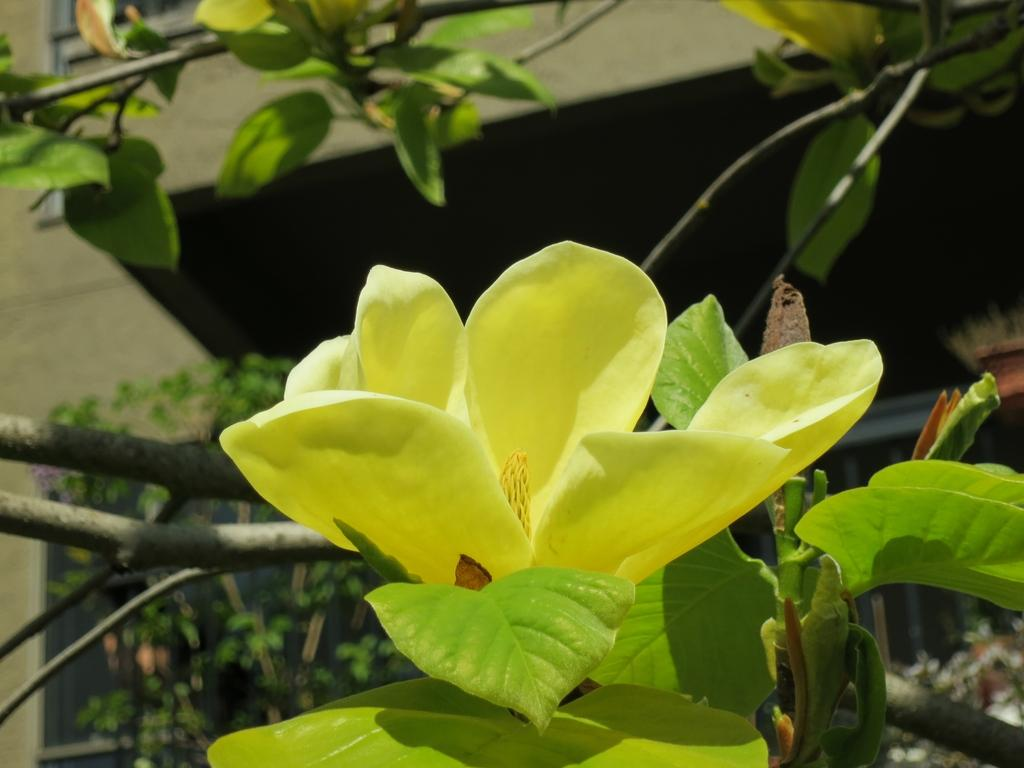What type of plant is featured in the image? There is a plant with a flower and leaves in the image. Are there any other plants visible in the image? Yes, there are branches with leaves and flowers in the image. What can be seen in the background of the image? There are plants and a building visible in the background of the image. What language is the plant speaking in the image? Plants do not speak languages, so this question cannot be answered. 